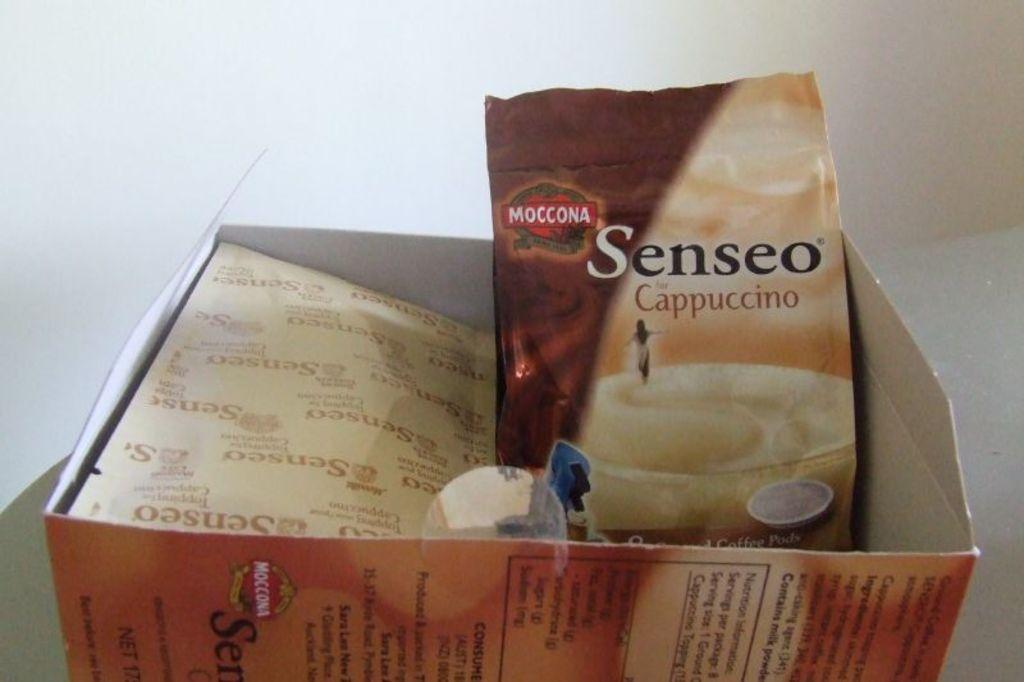What type of coffee is it?
Provide a succinct answer. Cappuccino. Whats in the box?
Your answer should be compact. Senseo. 